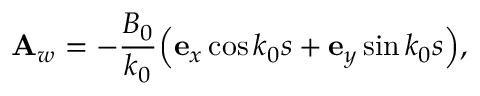<formula> <loc_0><loc_0><loc_500><loc_500>{ A } _ { w } = - { \frac { B _ { 0 } } { k _ { 0 } } } { \left ( { e } _ { x } \cos k _ { 0 } s + { e } _ { y } \sin k _ { 0 } s \right ) } ,</formula> 